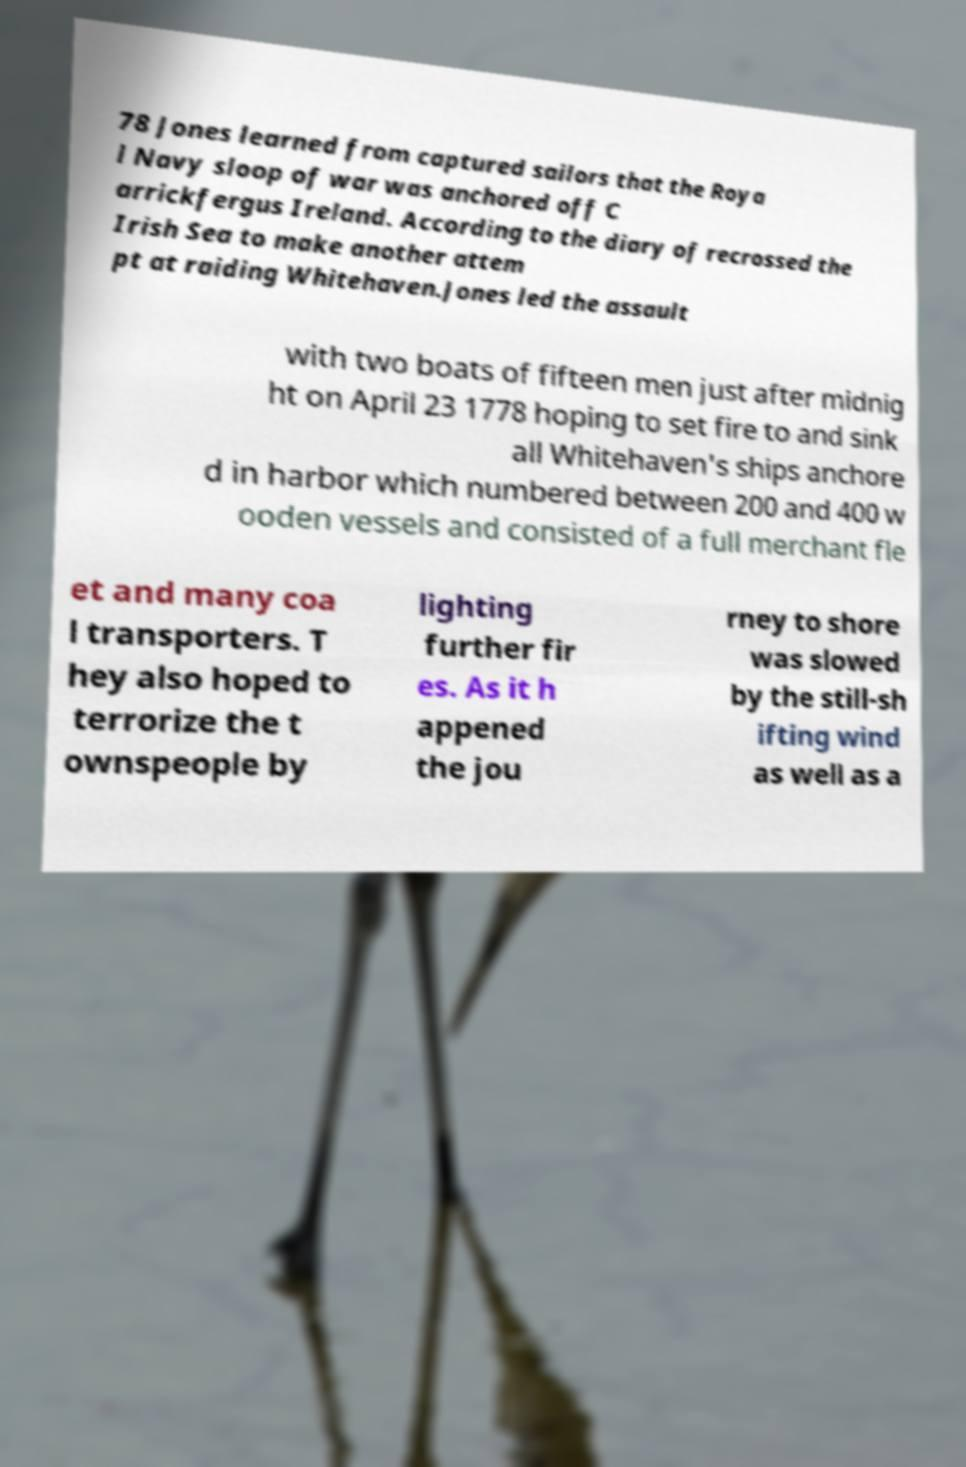Please identify and transcribe the text found in this image. 78 Jones learned from captured sailors that the Roya l Navy sloop of war was anchored off C arrickfergus Ireland. According to the diary of recrossed the Irish Sea to make another attem pt at raiding Whitehaven.Jones led the assault with two boats of fifteen men just after midnig ht on April 23 1778 hoping to set fire to and sink all Whitehaven's ships anchore d in harbor which numbered between 200 and 400 w ooden vessels and consisted of a full merchant fle et and many coa l transporters. T hey also hoped to terrorize the t ownspeople by lighting further fir es. As it h appened the jou rney to shore was slowed by the still-sh ifting wind as well as a 